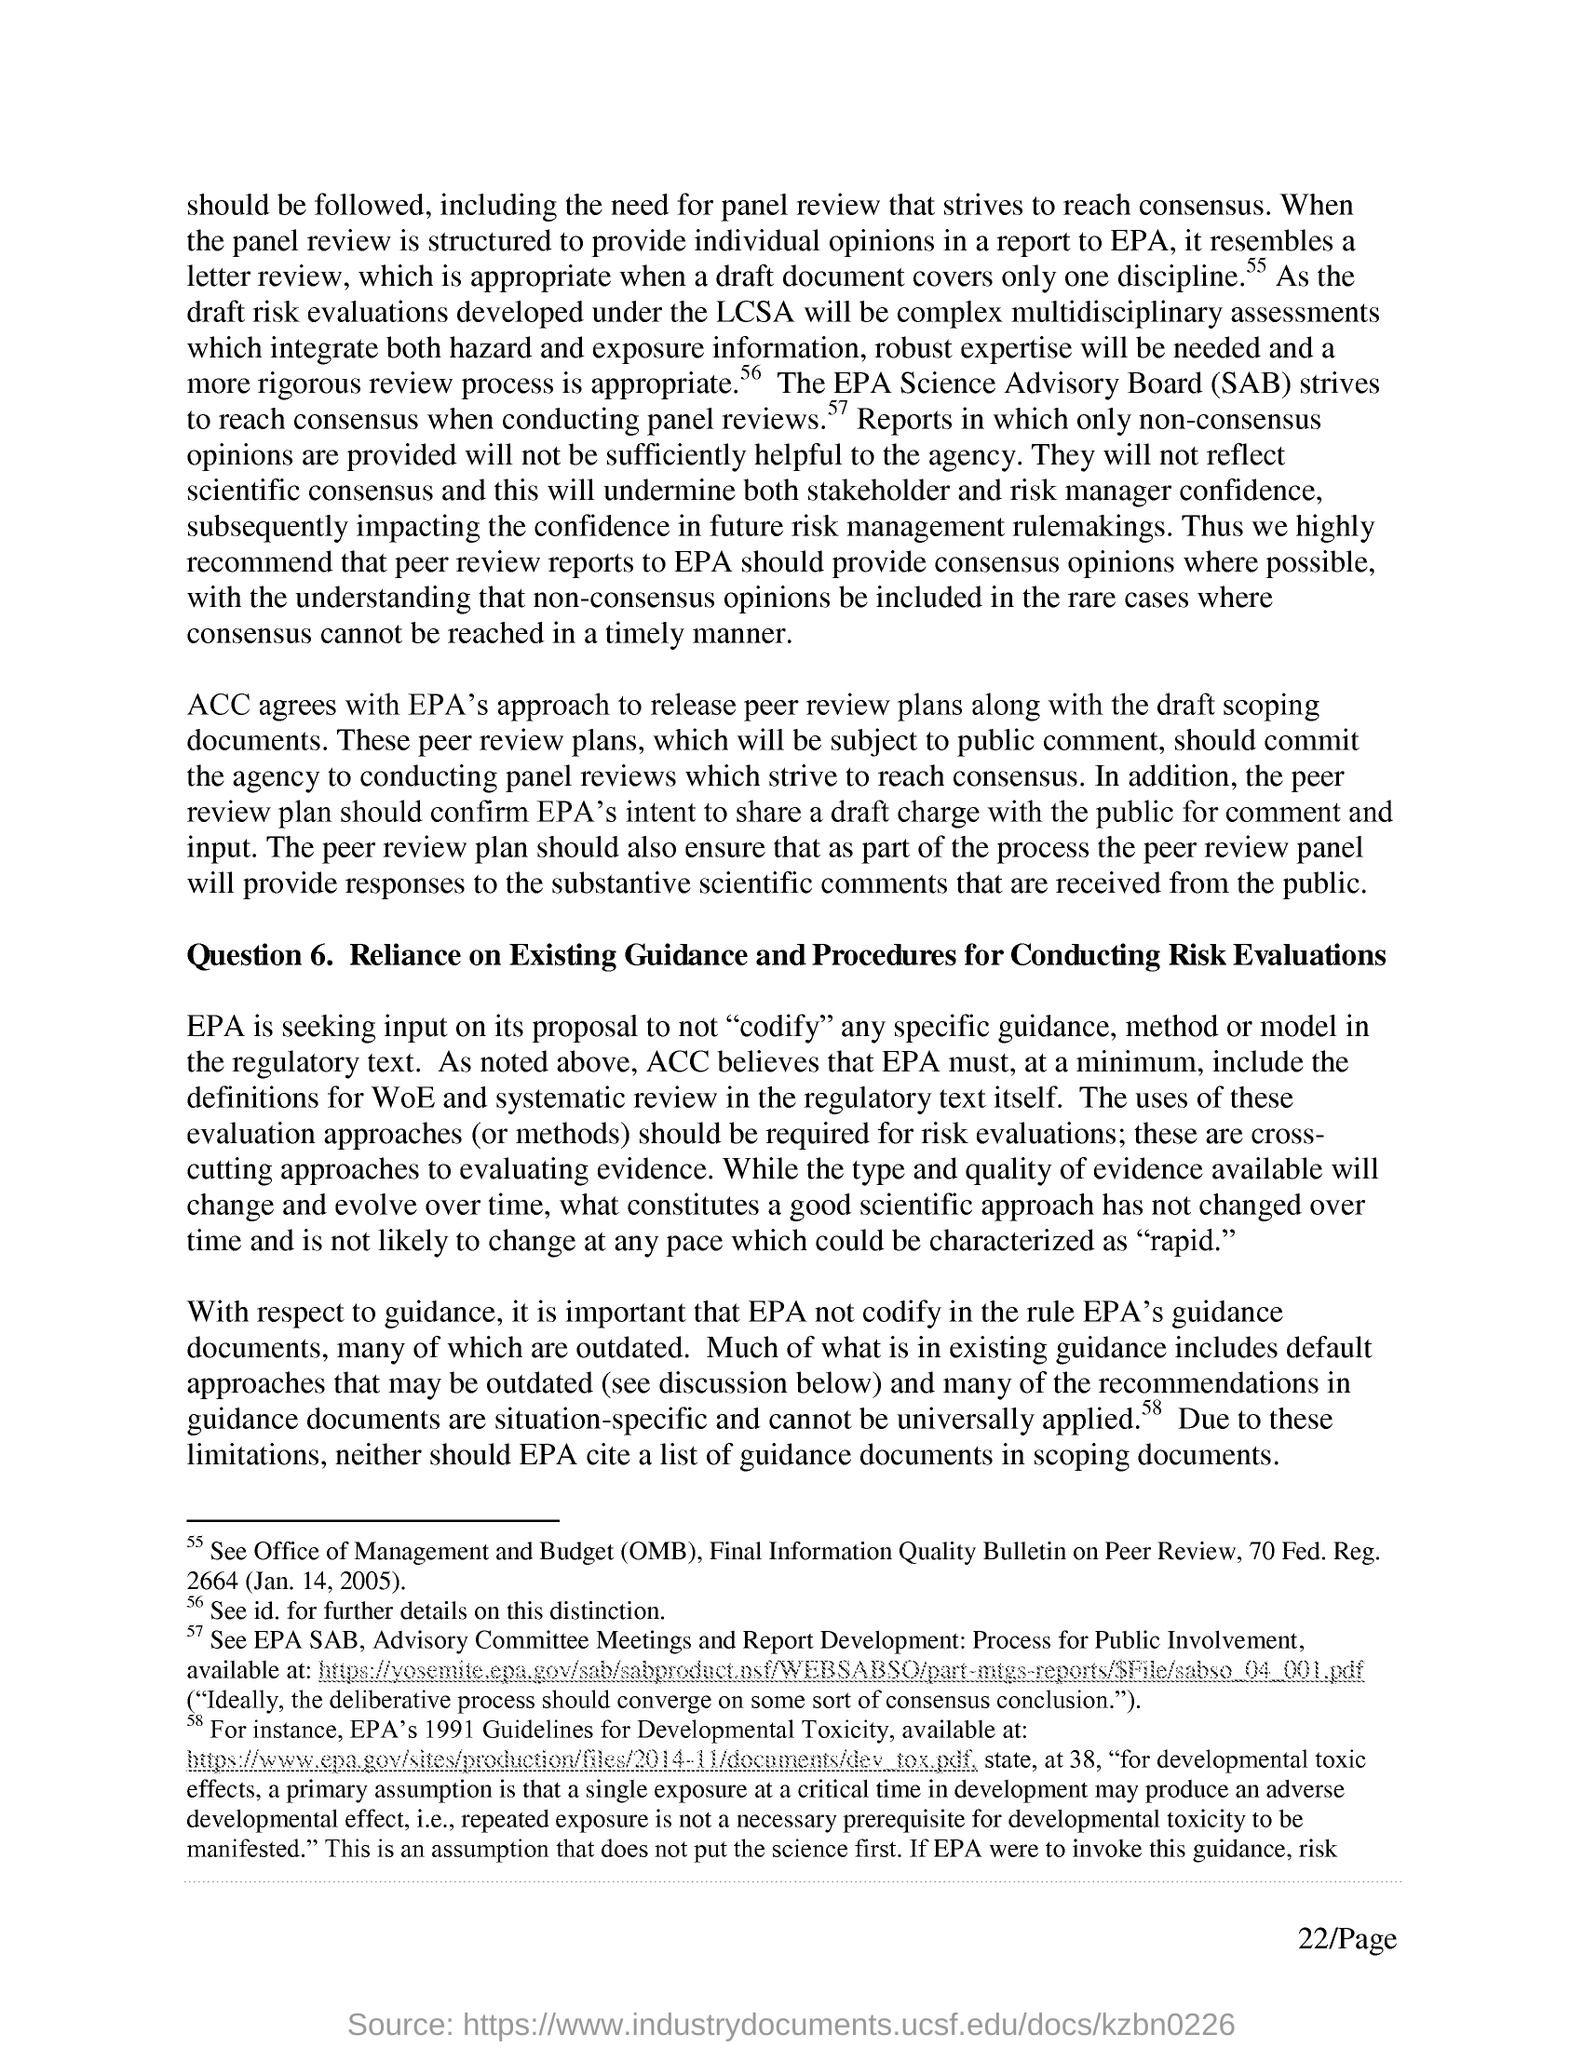What is the full form of OMB?
Make the answer very short. Office of management and budget. 